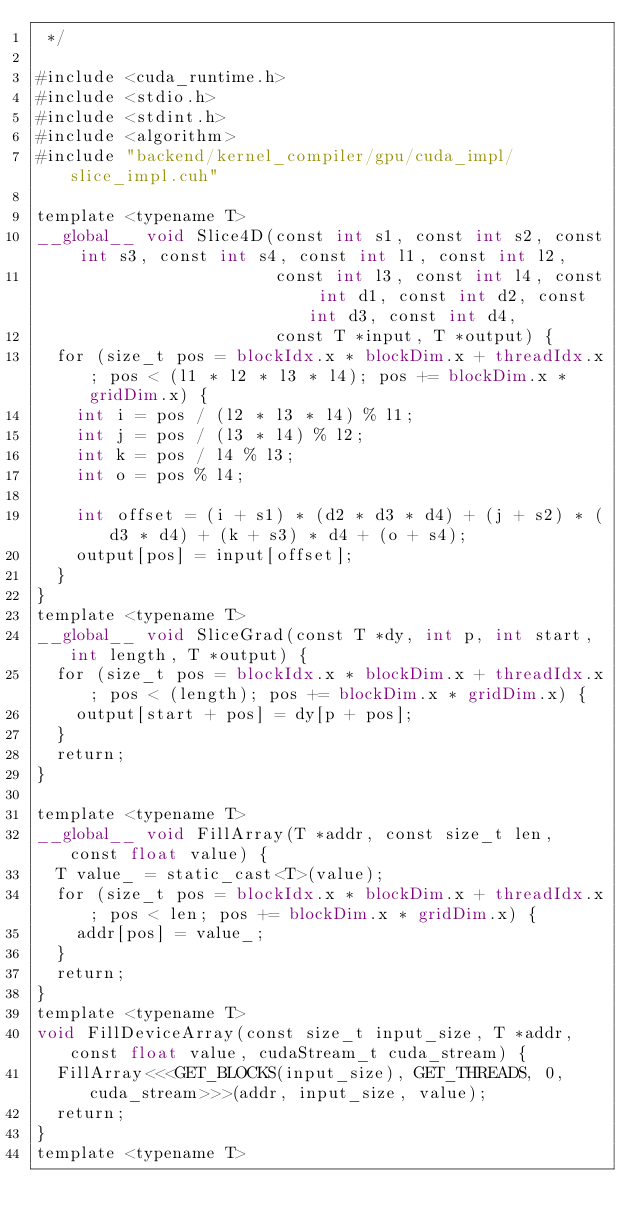Convert code to text. <code><loc_0><loc_0><loc_500><loc_500><_Cuda_> */

#include <cuda_runtime.h>
#include <stdio.h>
#include <stdint.h>
#include <algorithm>
#include "backend/kernel_compiler/gpu/cuda_impl/slice_impl.cuh"

template <typename T>
__global__ void Slice4D(const int s1, const int s2, const int s3, const int s4, const int l1, const int l2,
                        const int l3, const int l4, const int d1, const int d2, const int d3, const int d4,
                        const T *input, T *output) {
  for (size_t pos = blockIdx.x * blockDim.x + threadIdx.x; pos < (l1 * l2 * l3 * l4); pos += blockDim.x * gridDim.x) {
    int i = pos / (l2 * l3 * l4) % l1;
    int j = pos / (l3 * l4) % l2;
    int k = pos / l4 % l3;
    int o = pos % l4;

    int offset = (i + s1) * (d2 * d3 * d4) + (j + s2) * (d3 * d4) + (k + s3) * d4 + (o + s4);
    output[pos] = input[offset];
  }
}
template <typename T>
__global__ void SliceGrad(const T *dy, int p, int start, int length, T *output) {
  for (size_t pos = blockIdx.x * blockDim.x + threadIdx.x; pos < (length); pos += blockDim.x * gridDim.x) {
    output[start + pos] = dy[p + pos];
  }
  return;
}

template <typename T>
__global__ void FillArray(T *addr, const size_t len, const float value) {
  T value_ = static_cast<T>(value);
  for (size_t pos = blockIdx.x * blockDim.x + threadIdx.x; pos < len; pos += blockDim.x * gridDim.x) {
    addr[pos] = value_;
  }
  return;
}
template <typename T>
void FillDeviceArray(const size_t input_size, T *addr, const float value, cudaStream_t cuda_stream) {
  FillArray<<<GET_BLOCKS(input_size), GET_THREADS, 0, cuda_stream>>>(addr, input_size, value);
  return;
}
template <typename T></code> 